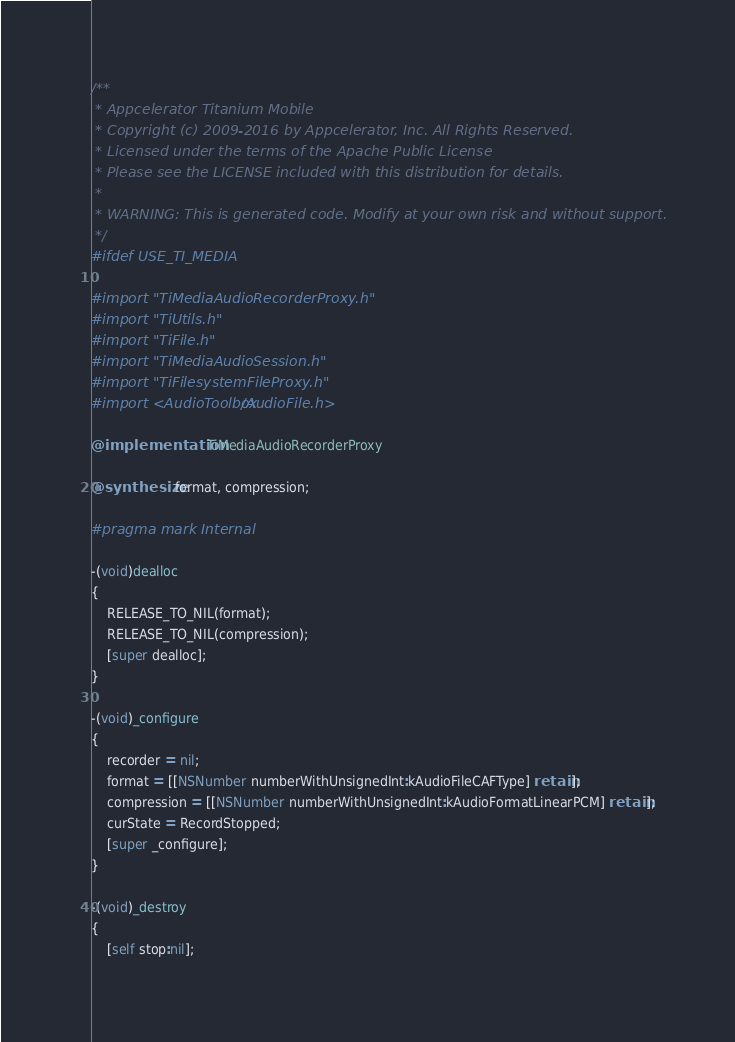<code> <loc_0><loc_0><loc_500><loc_500><_ObjectiveC_>/**
 * Appcelerator Titanium Mobile
 * Copyright (c) 2009-2016 by Appcelerator, Inc. All Rights Reserved.
 * Licensed under the terms of the Apache Public License
 * Please see the LICENSE included with this distribution for details.
 * 
 * WARNING: This is generated code. Modify at your own risk and without support.
 */
#ifdef USE_TI_MEDIA

#import "TiMediaAudioRecorderProxy.h"
#import "TiUtils.h"
#import "TiFile.h"
#import "TiMediaAudioSession.h"
#import "TiFilesystemFileProxy.h"
#import <AudioToolbox/AudioFile.h>

@implementation TiMediaAudioRecorderProxy

@synthesize format, compression;

#pragma mark Internal

-(void)dealloc
{
    RELEASE_TO_NIL(format);
    RELEASE_TO_NIL(compression);
    [super dealloc];
}

-(void)_configure
{
    recorder = nil;
    format = [[NSNumber numberWithUnsignedInt:kAudioFileCAFType] retain];
    compression = [[NSNumber numberWithUnsignedInt:kAudioFormatLinearPCM] retain];
    curState = RecordStopped;
    [super _configure];
}

-(void)_destroy
{
    [self stop:nil];</code> 